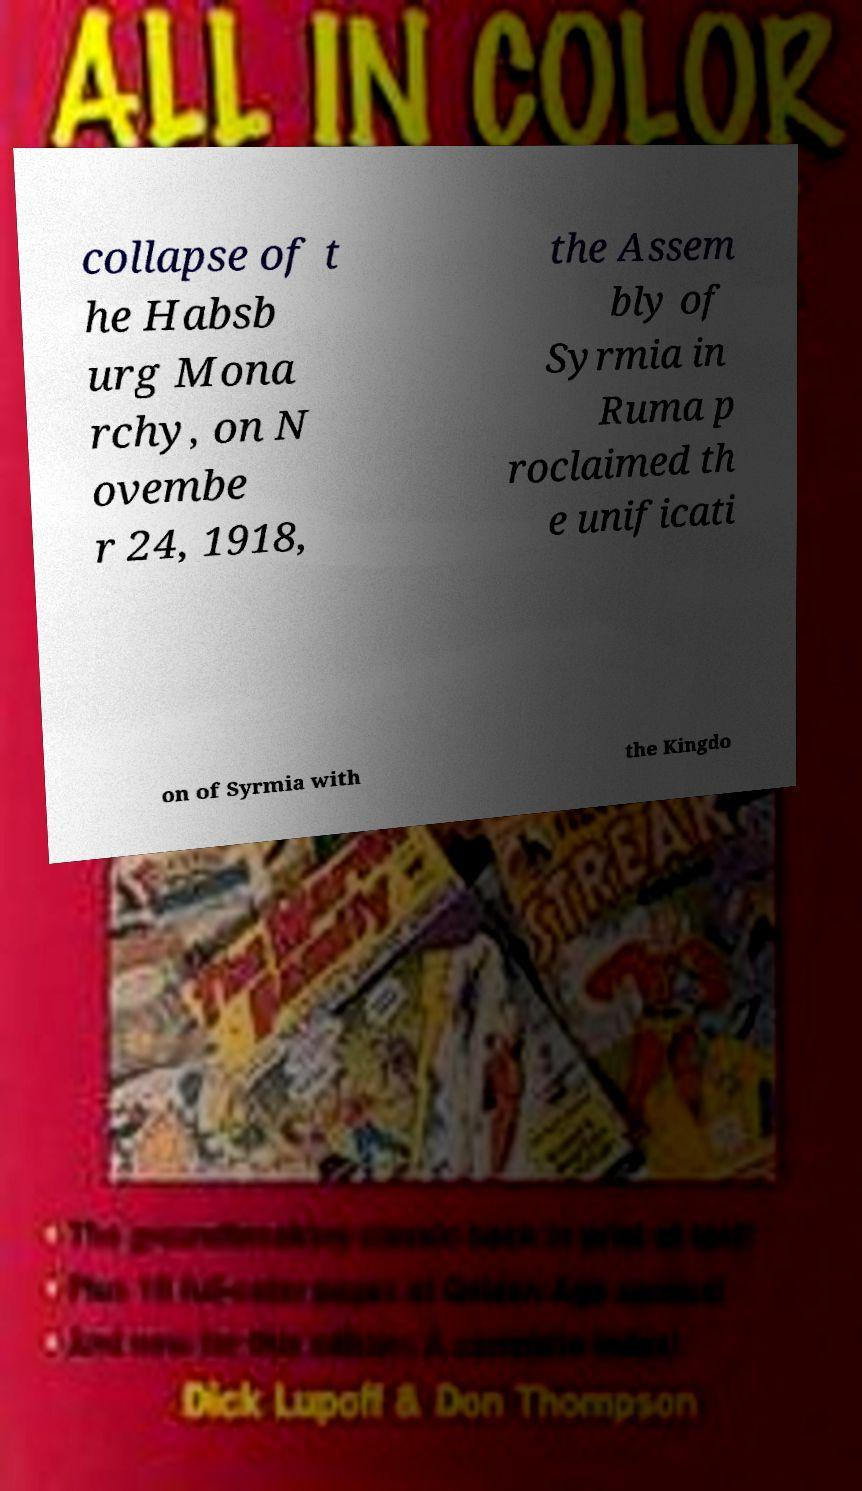Can you read and provide the text displayed in the image?This photo seems to have some interesting text. Can you extract and type it out for me? collapse of t he Habsb urg Mona rchy, on N ovembe r 24, 1918, the Assem bly of Syrmia in Ruma p roclaimed th e unificati on of Syrmia with the Kingdo 